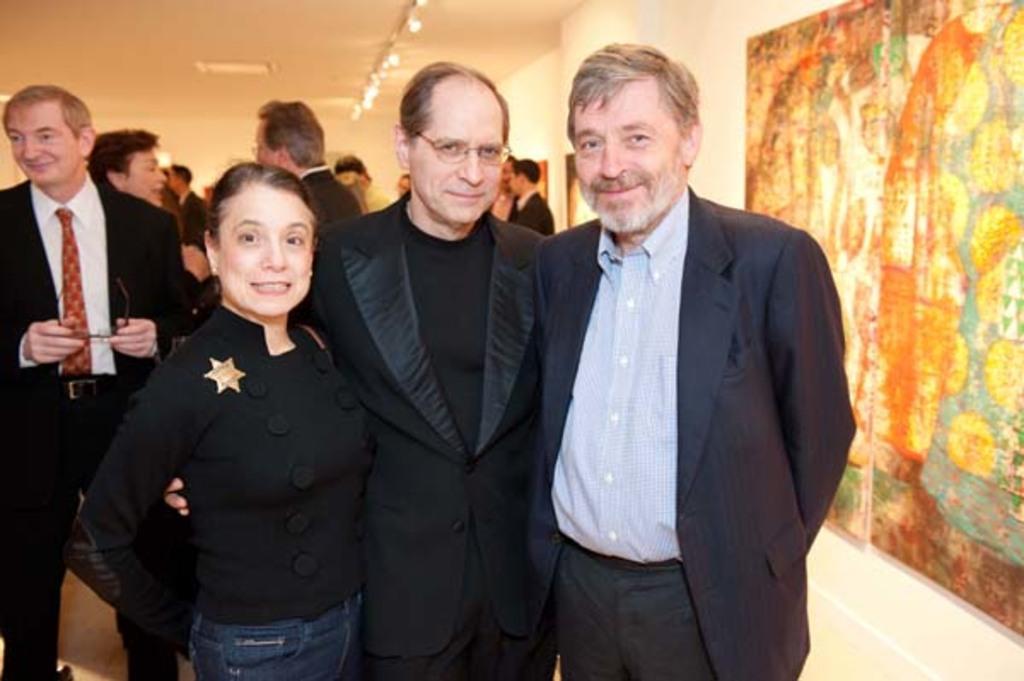In one or two sentences, can you explain what this image depicts? In the picture there are many people gathered in a room and in the front three people was standing and posing for the photo, on the right side there is a poster kept in front of a wall. 